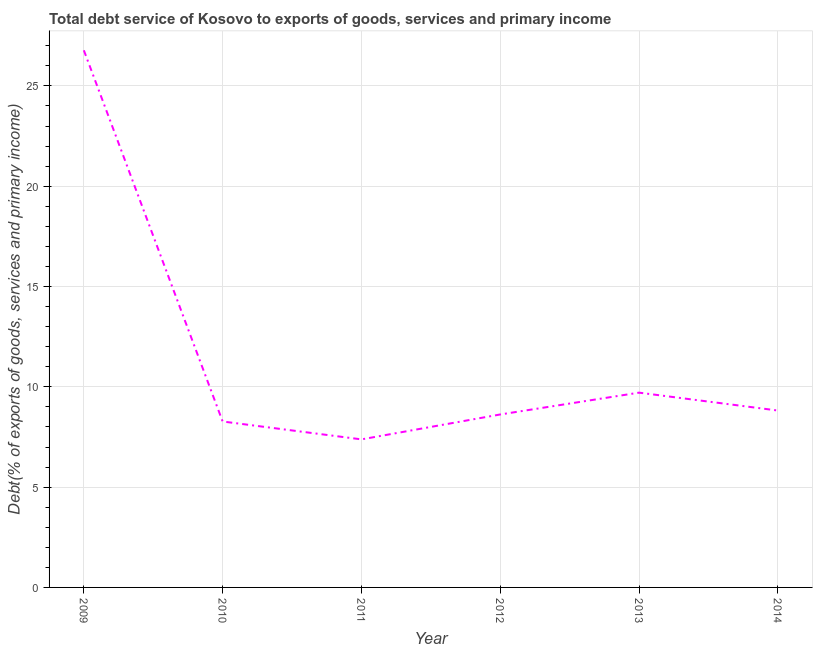What is the total debt service in 2009?
Ensure brevity in your answer.  26.78. Across all years, what is the maximum total debt service?
Your answer should be compact. 26.78. Across all years, what is the minimum total debt service?
Keep it short and to the point. 7.38. In which year was the total debt service minimum?
Your answer should be compact. 2011. What is the sum of the total debt service?
Ensure brevity in your answer.  69.58. What is the difference between the total debt service in 2009 and 2013?
Your answer should be very brief. 17.07. What is the average total debt service per year?
Make the answer very short. 11.6. What is the median total debt service?
Make the answer very short. 8.72. What is the ratio of the total debt service in 2009 to that in 2013?
Make the answer very short. 2.76. Is the difference between the total debt service in 2012 and 2013 greater than the difference between any two years?
Your answer should be very brief. No. What is the difference between the highest and the second highest total debt service?
Keep it short and to the point. 17.07. What is the difference between the highest and the lowest total debt service?
Give a very brief answer. 19.4. In how many years, is the total debt service greater than the average total debt service taken over all years?
Your response must be concise. 1. How many years are there in the graph?
Your response must be concise. 6. Does the graph contain grids?
Provide a succinct answer. Yes. What is the title of the graph?
Your answer should be very brief. Total debt service of Kosovo to exports of goods, services and primary income. What is the label or title of the X-axis?
Your response must be concise. Year. What is the label or title of the Y-axis?
Ensure brevity in your answer.  Debt(% of exports of goods, services and primary income). What is the Debt(% of exports of goods, services and primary income) of 2009?
Keep it short and to the point. 26.78. What is the Debt(% of exports of goods, services and primary income) of 2010?
Your answer should be compact. 8.27. What is the Debt(% of exports of goods, services and primary income) in 2011?
Your response must be concise. 7.38. What is the Debt(% of exports of goods, services and primary income) in 2012?
Your response must be concise. 8.62. What is the Debt(% of exports of goods, services and primary income) of 2013?
Your answer should be compact. 9.71. What is the Debt(% of exports of goods, services and primary income) of 2014?
Provide a short and direct response. 8.82. What is the difference between the Debt(% of exports of goods, services and primary income) in 2009 and 2010?
Make the answer very short. 18.5. What is the difference between the Debt(% of exports of goods, services and primary income) in 2009 and 2011?
Provide a short and direct response. 19.4. What is the difference between the Debt(% of exports of goods, services and primary income) in 2009 and 2012?
Give a very brief answer. 18.15. What is the difference between the Debt(% of exports of goods, services and primary income) in 2009 and 2013?
Ensure brevity in your answer.  17.07. What is the difference between the Debt(% of exports of goods, services and primary income) in 2009 and 2014?
Your response must be concise. 17.96. What is the difference between the Debt(% of exports of goods, services and primary income) in 2010 and 2011?
Keep it short and to the point. 0.89. What is the difference between the Debt(% of exports of goods, services and primary income) in 2010 and 2012?
Give a very brief answer. -0.35. What is the difference between the Debt(% of exports of goods, services and primary income) in 2010 and 2013?
Ensure brevity in your answer.  -1.44. What is the difference between the Debt(% of exports of goods, services and primary income) in 2010 and 2014?
Offer a very short reply. -0.55. What is the difference between the Debt(% of exports of goods, services and primary income) in 2011 and 2012?
Make the answer very short. -1.24. What is the difference between the Debt(% of exports of goods, services and primary income) in 2011 and 2013?
Make the answer very short. -2.33. What is the difference between the Debt(% of exports of goods, services and primary income) in 2011 and 2014?
Your response must be concise. -1.44. What is the difference between the Debt(% of exports of goods, services and primary income) in 2012 and 2013?
Make the answer very short. -1.09. What is the difference between the Debt(% of exports of goods, services and primary income) in 2012 and 2014?
Offer a very short reply. -0.2. What is the difference between the Debt(% of exports of goods, services and primary income) in 2013 and 2014?
Provide a succinct answer. 0.89. What is the ratio of the Debt(% of exports of goods, services and primary income) in 2009 to that in 2010?
Provide a short and direct response. 3.24. What is the ratio of the Debt(% of exports of goods, services and primary income) in 2009 to that in 2011?
Make the answer very short. 3.63. What is the ratio of the Debt(% of exports of goods, services and primary income) in 2009 to that in 2012?
Offer a very short reply. 3.11. What is the ratio of the Debt(% of exports of goods, services and primary income) in 2009 to that in 2013?
Your answer should be very brief. 2.76. What is the ratio of the Debt(% of exports of goods, services and primary income) in 2009 to that in 2014?
Give a very brief answer. 3.04. What is the ratio of the Debt(% of exports of goods, services and primary income) in 2010 to that in 2011?
Your answer should be very brief. 1.12. What is the ratio of the Debt(% of exports of goods, services and primary income) in 2010 to that in 2012?
Ensure brevity in your answer.  0.96. What is the ratio of the Debt(% of exports of goods, services and primary income) in 2010 to that in 2013?
Provide a short and direct response. 0.85. What is the ratio of the Debt(% of exports of goods, services and primary income) in 2010 to that in 2014?
Offer a terse response. 0.94. What is the ratio of the Debt(% of exports of goods, services and primary income) in 2011 to that in 2012?
Provide a succinct answer. 0.86. What is the ratio of the Debt(% of exports of goods, services and primary income) in 2011 to that in 2013?
Your answer should be compact. 0.76. What is the ratio of the Debt(% of exports of goods, services and primary income) in 2011 to that in 2014?
Provide a succinct answer. 0.84. What is the ratio of the Debt(% of exports of goods, services and primary income) in 2012 to that in 2013?
Give a very brief answer. 0.89. What is the ratio of the Debt(% of exports of goods, services and primary income) in 2012 to that in 2014?
Your answer should be compact. 0.98. What is the ratio of the Debt(% of exports of goods, services and primary income) in 2013 to that in 2014?
Make the answer very short. 1.1. 